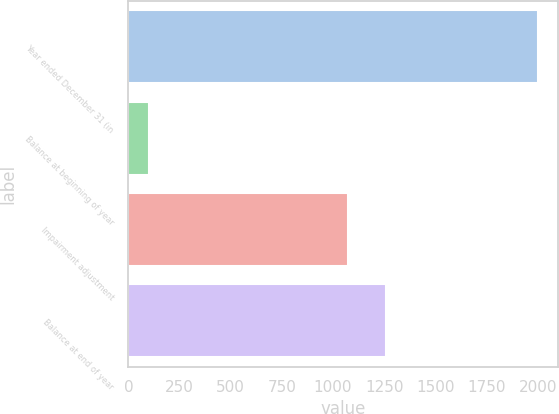Convert chart. <chart><loc_0><loc_0><loc_500><loc_500><bar_chart><fcel>Year ended December 31 (in<fcel>Balance at beginning of year<fcel>Impairment adjustment<fcel>Balance at end of year<nl><fcel>2001<fcel>99<fcel>1071<fcel>1261.2<nl></chart> 